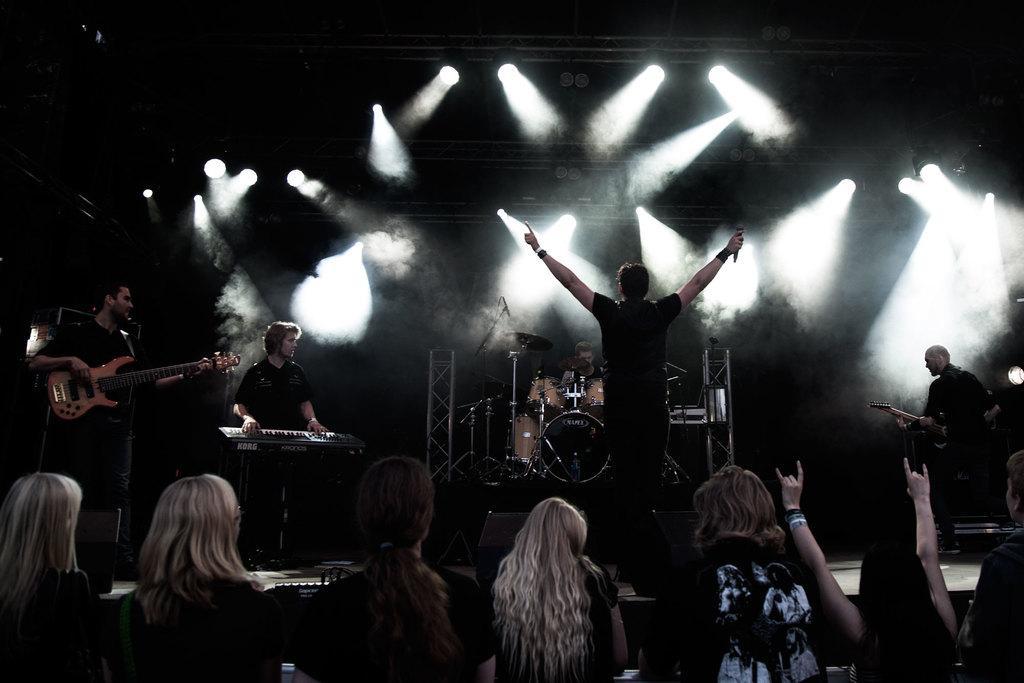Could you give a brief overview of what you see in this image? In this picture there is a group of people who are performing the music event on the stage and, the one who is at the middle of the image is turned towards the back by raising his hands and there are group of audience before the stage, there are different types of music instruments on the stage and there are spotlights above the image on the stage. 